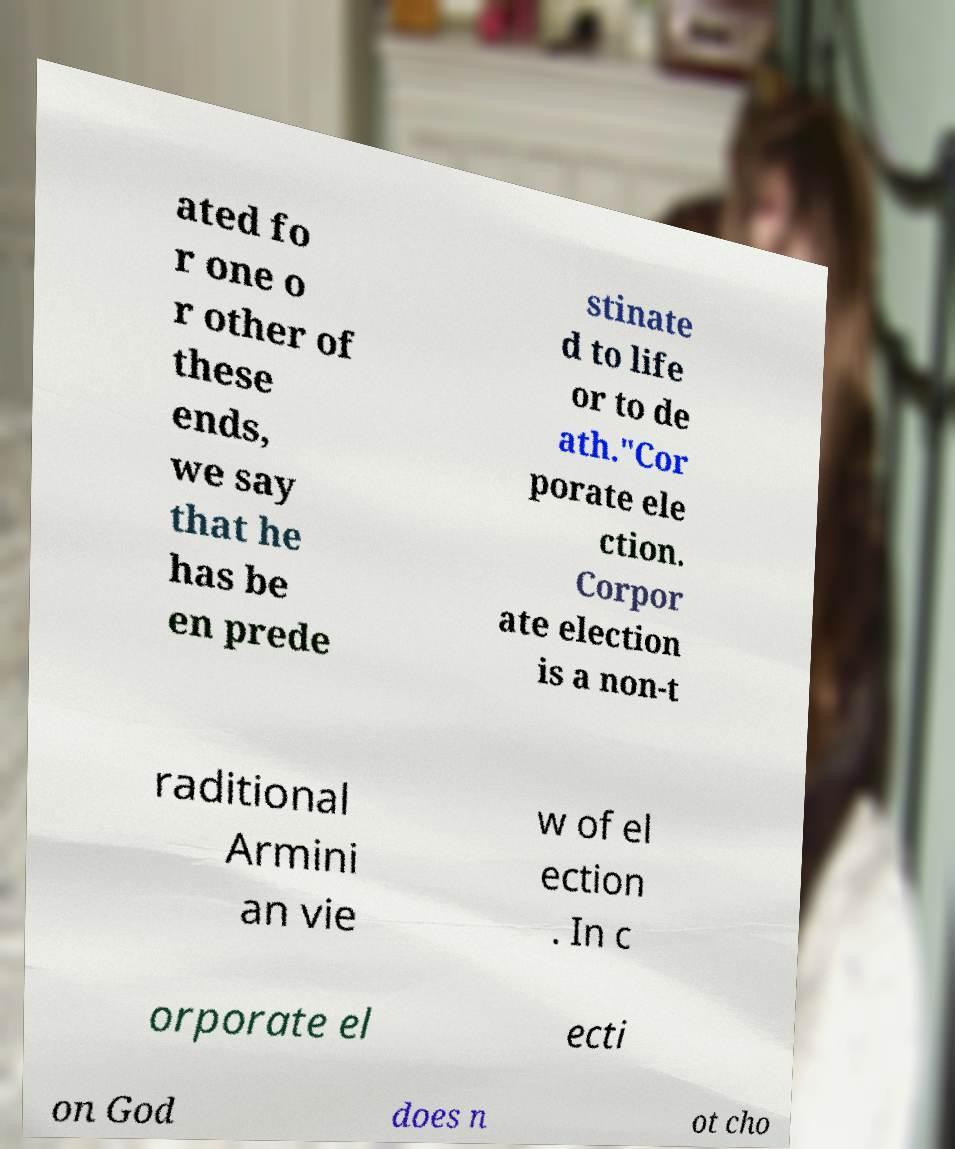What messages or text are displayed in this image? I need them in a readable, typed format. ated fo r one o r other of these ends, we say that he has be en prede stinate d to life or to de ath."Cor porate ele ction. Corpor ate election is a non-t raditional Armini an vie w of el ection . In c orporate el ecti on God does n ot cho 